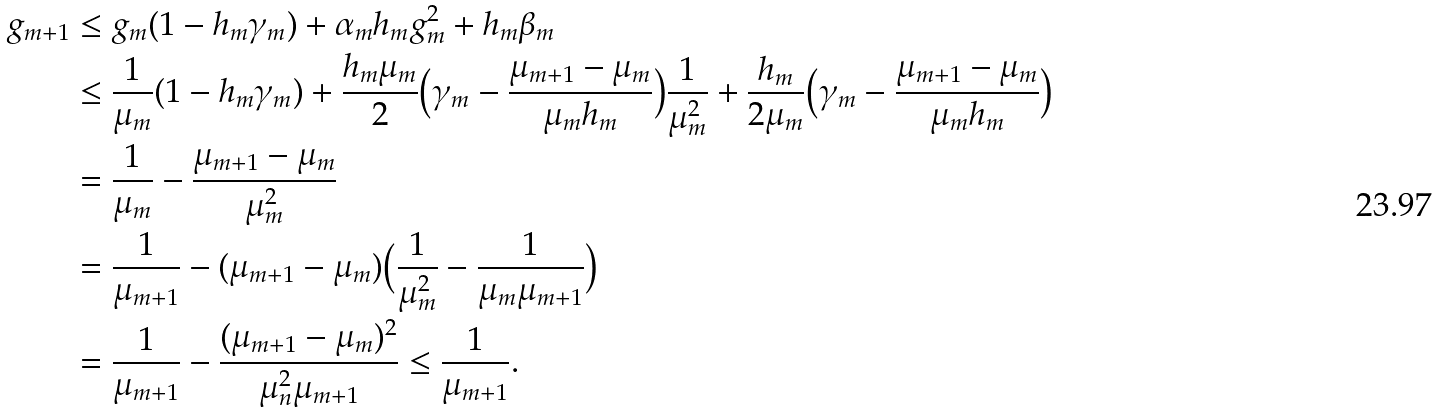<formula> <loc_0><loc_0><loc_500><loc_500>g _ { m + 1 } & \leq g _ { m } ( 1 - h _ { m } \gamma _ { m } ) + \alpha _ { m } h _ { m } g _ { m } ^ { 2 } + h _ { m } \beta _ { m } \\ & \leq \frac { 1 } { \mu _ { m } } ( 1 - h _ { m } \gamma _ { m } ) + \frac { h _ { m } \mu _ { m } } { 2 } \Big { ( } \gamma _ { m } - \frac { \mu _ { m + 1 } - \mu _ { m } } { \mu _ { m } h _ { m } } \Big { ) } \frac { 1 } { \mu _ { m } ^ { 2 } } + \frac { h _ { m } } { 2 \mu _ { m } } \Big { ( } \gamma _ { m } - \frac { \mu _ { m + 1 } - \mu _ { m } } { \mu _ { m } h _ { m } } \Big { ) } \\ & = \frac { 1 } { \mu _ { m } } - \frac { \mu _ { m + 1 } - \mu _ { m } } { \mu _ { m } ^ { 2 } } \\ & = \frac { 1 } { \mu _ { m + 1 } } - ( \mu _ { m + 1 } - \mu _ { m } ) \Big { ( } \frac { 1 } { \mu _ { m } ^ { 2 } } - \frac { 1 } { \mu _ { m } \mu _ { m + 1 } } \Big { ) } \\ & = \frac { 1 } { \mu _ { m + 1 } } - \frac { ( \mu _ { m + 1 } - \mu _ { m } ) ^ { 2 } } { \mu _ { n } ^ { 2 } \mu _ { m + 1 } } \leq \frac { 1 } { \mu _ { m + 1 } } .</formula> 